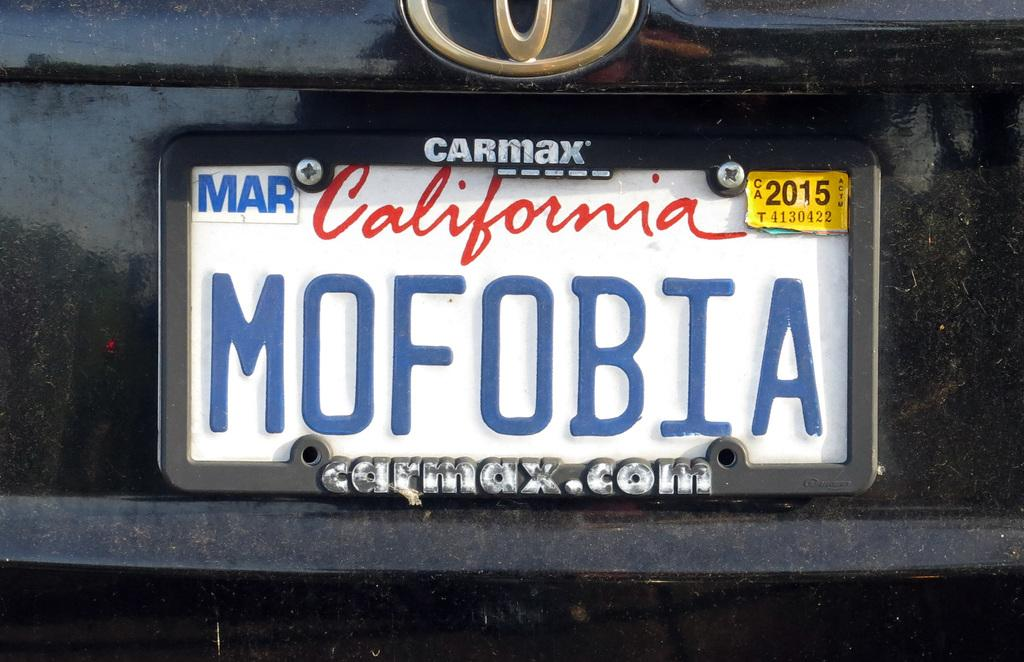<image>
Offer a succinct explanation of the picture presented. A license plate has a Carmax logo and the year 2015. 